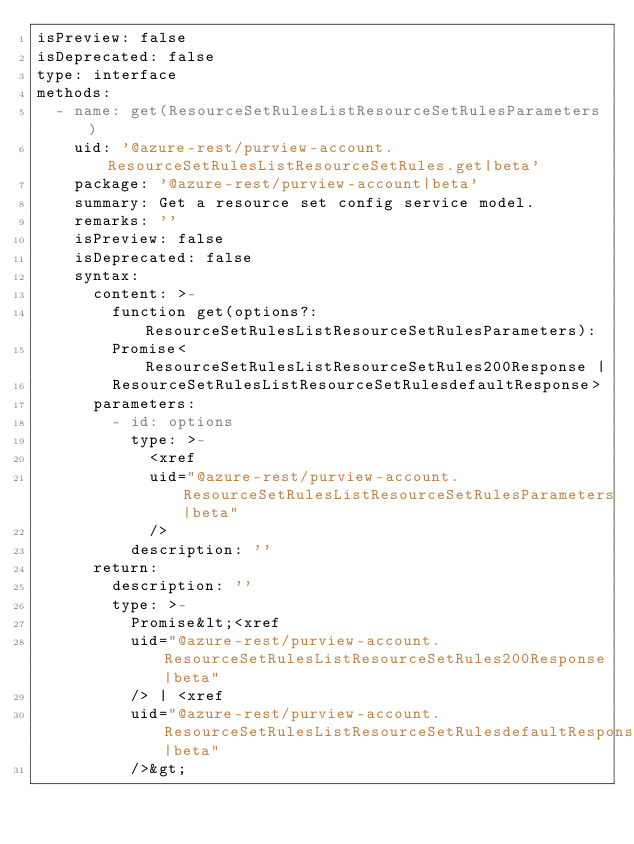<code> <loc_0><loc_0><loc_500><loc_500><_YAML_>isPreview: false
isDeprecated: false
type: interface
methods:
  - name: get(ResourceSetRulesListResourceSetRulesParameters)
    uid: '@azure-rest/purview-account.ResourceSetRulesListResourceSetRules.get|beta'
    package: '@azure-rest/purview-account|beta'
    summary: Get a resource set config service model.
    remarks: ''
    isPreview: false
    isDeprecated: false
    syntax:
      content: >-
        function get(options?: ResourceSetRulesListResourceSetRulesParameters):
        Promise<ResourceSetRulesListResourceSetRules200Response |
        ResourceSetRulesListResourceSetRulesdefaultResponse>
      parameters:
        - id: options
          type: >-
            <xref
            uid="@azure-rest/purview-account.ResourceSetRulesListResourceSetRulesParameters|beta"
            />
          description: ''
      return:
        description: ''
        type: >-
          Promise&lt;<xref
          uid="@azure-rest/purview-account.ResourceSetRulesListResourceSetRules200Response|beta"
          /> | <xref
          uid="@azure-rest/purview-account.ResourceSetRulesListResourceSetRulesdefaultResponse|beta"
          />&gt;
</code> 